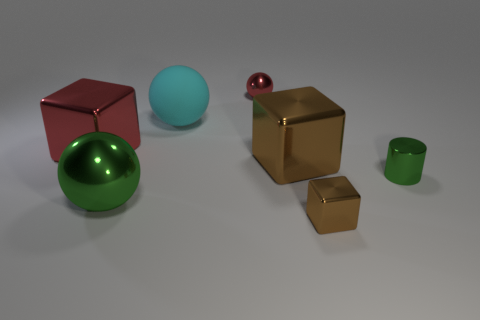Is there anything else that is the same material as the large cyan ball?
Your answer should be very brief. No. How big is the cube left of the big sphere right of the ball in front of the tiny green cylinder?
Your response must be concise. Large. Is the material of the green thing on the right side of the large green thing the same as the big cube on the right side of the large red metallic block?
Your answer should be very brief. Yes. What number of other things are there of the same color as the shiny cylinder?
Your response must be concise. 1. What number of things are tiny things behind the cyan rubber object or balls that are in front of the red ball?
Provide a short and direct response. 3. There is a green object right of the metal ball that is in front of the big brown cube; how big is it?
Give a very brief answer. Small. What is the size of the green ball?
Your answer should be very brief. Large. Is the color of the tiny object that is on the right side of the tiny brown cube the same as the large ball on the left side of the big cyan rubber object?
Keep it short and to the point. Yes. How many other things are there of the same material as the red ball?
Keep it short and to the point. 5. Is there a green metallic ball?
Provide a short and direct response. Yes. 